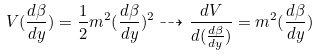Convert formula to latex. <formula><loc_0><loc_0><loc_500><loc_500>V ( \frac { d \beta } { d y } ) = \frac { 1 } { 2 } m ^ { 2 } ( \frac { d \beta } { d y } ) ^ { 2 } \dashrightarrow \frac { d V } { d ( \frac { d \beta } { d y } ) } = m ^ { 2 } ( \frac { d \beta } { d y } )</formula> 